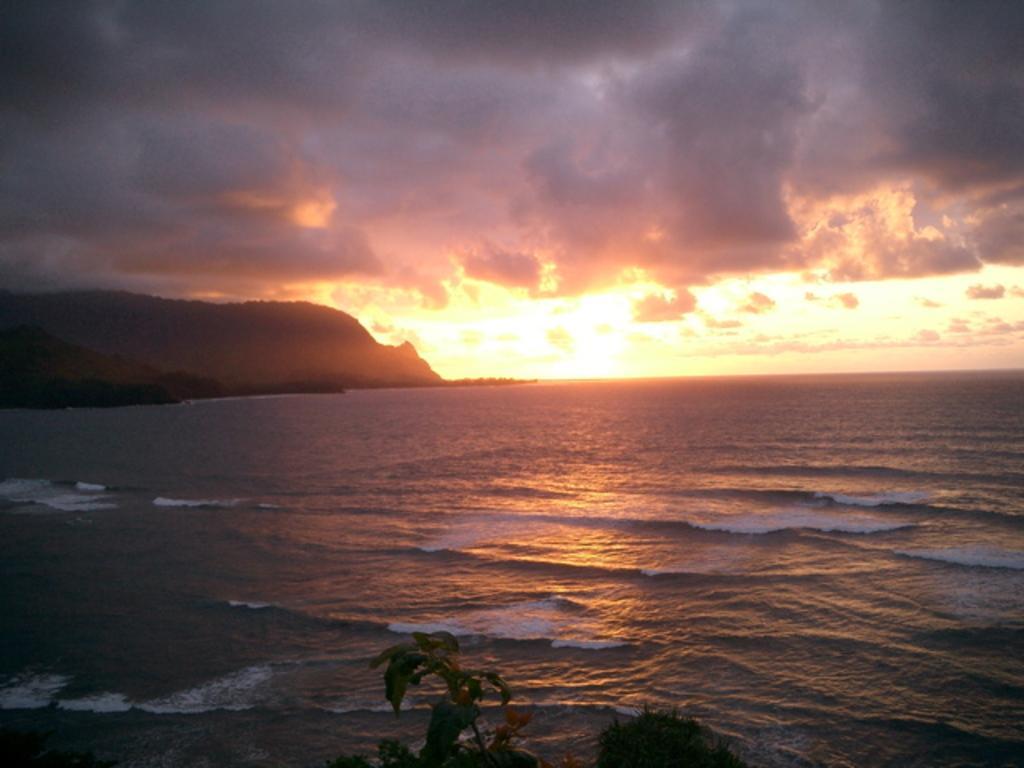In one or two sentences, can you explain what this image depicts? In this image in the front there is a plant. In the background there is an ocean and there are mountains and the sky is cloudy. 